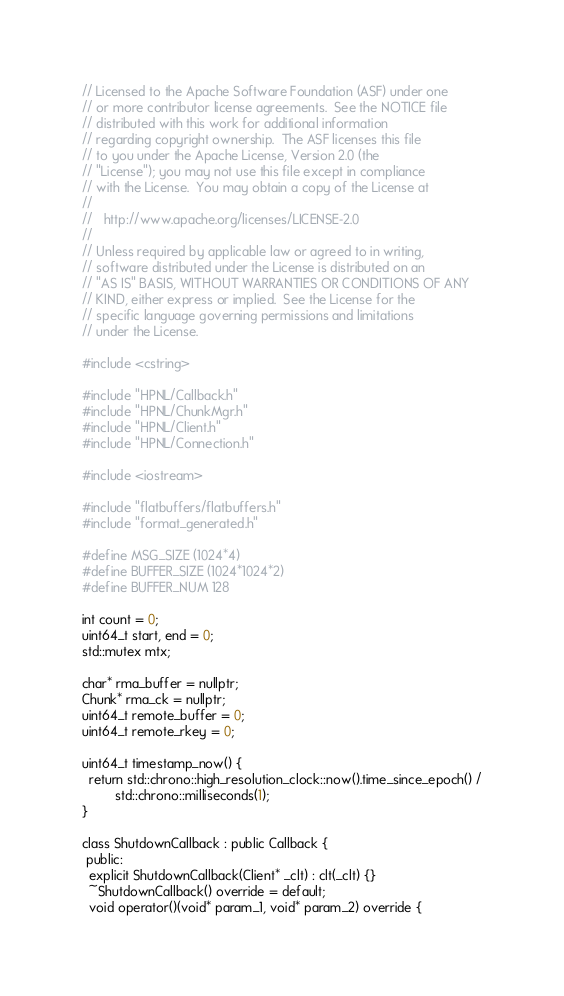Convert code to text. <code><loc_0><loc_0><loc_500><loc_500><_C++_>// Licensed to the Apache Software Foundation (ASF) under one
// or more contributor license agreements.  See the NOTICE file
// distributed with this work for additional information
// regarding copyright ownership.  The ASF licenses this file
// to you under the Apache License, Version 2.0 (the
// "License"); you may not use this file except in compliance
// with the License.  You may obtain a copy of the License at
//
//   http://www.apache.org/licenses/LICENSE-2.0
//
// Unless required by applicable law or agreed to in writing,
// software distributed under the License is distributed on an
// "AS IS" BASIS, WITHOUT WARRANTIES OR CONDITIONS OF ANY
// KIND, either express or implied.  See the License for the
// specific language governing permissions and limitations
// under the License.

#include <cstring>

#include "HPNL/Callback.h"
#include "HPNL/ChunkMgr.h"
#include "HPNL/Client.h"
#include "HPNL/Connection.h"

#include <iostream>

#include "flatbuffers/flatbuffers.h"
#include "format_generated.h"

#define MSG_SIZE (1024*4)
#define BUFFER_SIZE (1024*1024*2)
#define BUFFER_NUM 128

int count = 0;
uint64_t start, end = 0;
std::mutex mtx;

char* rma_buffer = nullptr;
Chunk* rma_ck = nullptr;
uint64_t remote_buffer = 0;
uint64_t remote_rkey = 0;

uint64_t timestamp_now() {
  return std::chrono::high_resolution_clock::now().time_since_epoch() /
         std::chrono::milliseconds(1);
}

class ShutdownCallback : public Callback {
 public:
  explicit ShutdownCallback(Client* _clt) : clt(_clt) {}
  ~ShutdownCallback() override = default;
  void operator()(void* param_1, void* param_2) override {</code> 